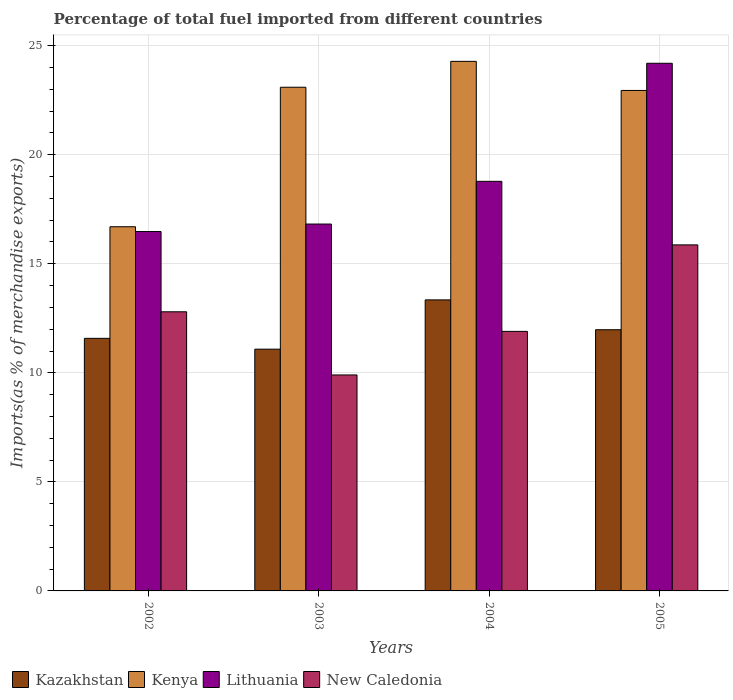How many groups of bars are there?
Your answer should be compact. 4. Are the number of bars per tick equal to the number of legend labels?
Your response must be concise. Yes. Are the number of bars on each tick of the X-axis equal?
Your answer should be compact. Yes. How many bars are there on the 1st tick from the right?
Your answer should be compact. 4. What is the label of the 1st group of bars from the left?
Your answer should be very brief. 2002. What is the percentage of imports to different countries in New Caledonia in 2005?
Give a very brief answer. 15.87. Across all years, what is the maximum percentage of imports to different countries in Kenya?
Provide a short and direct response. 24.28. Across all years, what is the minimum percentage of imports to different countries in Lithuania?
Provide a short and direct response. 16.48. In which year was the percentage of imports to different countries in New Caledonia maximum?
Provide a short and direct response. 2005. In which year was the percentage of imports to different countries in New Caledonia minimum?
Your answer should be very brief. 2003. What is the total percentage of imports to different countries in New Caledonia in the graph?
Keep it short and to the point. 50.47. What is the difference between the percentage of imports to different countries in New Caledonia in 2002 and that in 2004?
Keep it short and to the point. 0.9. What is the difference between the percentage of imports to different countries in Kenya in 2005 and the percentage of imports to different countries in New Caledonia in 2004?
Your answer should be very brief. 11.05. What is the average percentage of imports to different countries in Lithuania per year?
Offer a very short reply. 19.07. In the year 2005, what is the difference between the percentage of imports to different countries in New Caledonia and percentage of imports to different countries in Lithuania?
Your answer should be very brief. -8.33. In how many years, is the percentage of imports to different countries in Kenya greater than 4 %?
Your answer should be compact. 4. What is the ratio of the percentage of imports to different countries in New Caledonia in 2003 to that in 2004?
Provide a succinct answer. 0.83. Is the percentage of imports to different countries in Lithuania in 2003 less than that in 2005?
Provide a short and direct response. Yes. What is the difference between the highest and the second highest percentage of imports to different countries in New Caledonia?
Offer a terse response. 3.07. What is the difference between the highest and the lowest percentage of imports to different countries in Lithuania?
Make the answer very short. 7.72. Is the sum of the percentage of imports to different countries in Kenya in 2003 and 2005 greater than the maximum percentage of imports to different countries in Lithuania across all years?
Provide a succinct answer. Yes. Is it the case that in every year, the sum of the percentage of imports to different countries in New Caledonia and percentage of imports to different countries in Lithuania is greater than the sum of percentage of imports to different countries in Kenya and percentage of imports to different countries in Kazakhstan?
Keep it short and to the point. No. What does the 3rd bar from the left in 2003 represents?
Offer a terse response. Lithuania. What does the 1st bar from the right in 2005 represents?
Ensure brevity in your answer.  New Caledonia. What is the difference between two consecutive major ticks on the Y-axis?
Ensure brevity in your answer.  5. Are the values on the major ticks of Y-axis written in scientific E-notation?
Provide a short and direct response. No. Does the graph contain any zero values?
Provide a short and direct response. No. Does the graph contain grids?
Offer a very short reply. Yes. Where does the legend appear in the graph?
Ensure brevity in your answer.  Bottom left. How are the legend labels stacked?
Ensure brevity in your answer.  Horizontal. What is the title of the graph?
Give a very brief answer. Percentage of total fuel imported from different countries. What is the label or title of the Y-axis?
Ensure brevity in your answer.  Imports(as % of merchandise exports). What is the Imports(as % of merchandise exports) in Kazakhstan in 2002?
Provide a succinct answer. 11.58. What is the Imports(as % of merchandise exports) in Kenya in 2002?
Provide a succinct answer. 16.7. What is the Imports(as % of merchandise exports) of Lithuania in 2002?
Provide a short and direct response. 16.48. What is the Imports(as % of merchandise exports) in New Caledonia in 2002?
Provide a short and direct response. 12.8. What is the Imports(as % of merchandise exports) in Kazakhstan in 2003?
Provide a succinct answer. 11.09. What is the Imports(as % of merchandise exports) in Kenya in 2003?
Ensure brevity in your answer.  23.1. What is the Imports(as % of merchandise exports) of Lithuania in 2003?
Provide a short and direct response. 16.82. What is the Imports(as % of merchandise exports) in New Caledonia in 2003?
Ensure brevity in your answer.  9.9. What is the Imports(as % of merchandise exports) in Kazakhstan in 2004?
Your answer should be very brief. 13.35. What is the Imports(as % of merchandise exports) in Kenya in 2004?
Offer a terse response. 24.28. What is the Imports(as % of merchandise exports) in Lithuania in 2004?
Make the answer very short. 18.78. What is the Imports(as % of merchandise exports) in New Caledonia in 2004?
Keep it short and to the point. 11.9. What is the Imports(as % of merchandise exports) in Kazakhstan in 2005?
Your answer should be compact. 11.98. What is the Imports(as % of merchandise exports) in Kenya in 2005?
Offer a terse response. 22.95. What is the Imports(as % of merchandise exports) of Lithuania in 2005?
Keep it short and to the point. 24.2. What is the Imports(as % of merchandise exports) of New Caledonia in 2005?
Give a very brief answer. 15.87. Across all years, what is the maximum Imports(as % of merchandise exports) of Kazakhstan?
Make the answer very short. 13.35. Across all years, what is the maximum Imports(as % of merchandise exports) of Kenya?
Your answer should be very brief. 24.28. Across all years, what is the maximum Imports(as % of merchandise exports) of Lithuania?
Provide a short and direct response. 24.2. Across all years, what is the maximum Imports(as % of merchandise exports) of New Caledonia?
Provide a short and direct response. 15.87. Across all years, what is the minimum Imports(as % of merchandise exports) in Kazakhstan?
Your answer should be very brief. 11.09. Across all years, what is the minimum Imports(as % of merchandise exports) of Kenya?
Provide a succinct answer. 16.7. Across all years, what is the minimum Imports(as % of merchandise exports) of Lithuania?
Give a very brief answer. 16.48. Across all years, what is the minimum Imports(as % of merchandise exports) of New Caledonia?
Make the answer very short. 9.9. What is the total Imports(as % of merchandise exports) in Kazakhstan in the graph?
Offer a terse response. 47.99. What is the total Imports(as % of merchandise exports) in Kenya in the graph?
Your answer should be very brief. 87.03. What is the total Imports(as % of merchandise exports) in Lithuania in the graph?
Give a very brief answer. 76.28. What is the total Imports(as % of merchandise exports) in New Caledonia in the graph?
Offer a terse response. 50.47. What is the difference between the Imports(as % of merchandise exports) of Kazakhstan in 2002 and that in 2003?
Your response must be concise. 0.5. What is the difference between the Imports(as % of merchandise exports) of Kenya in 2002 and that in 2003?
Offer a terse response. -6.4. What is the difference between the Imports(as % of merchandise exports) in Lithuania in 2002 and that in 2003?
Provide a succinct answer. -0.34. What is the difference between the Imports(as % of merchandise exports) of New Caledonia in 2002 and that in 2003?
Offer a terse response. 2.9. What is the difference between the Imports(as % of merchandise exports) in Kazakhstan in 2002 and that in 2004?
Give a very brief answer. -1.76. What is the difference between the Imports(as % of merchandise exports) of Kenya in 2002 and that in 2004?
Make the answer very short. -7.58. What is the difference between the Imports(as % of merchandise exports) in Lithuania in 2002 and that in 2004?
Offer a very short reply. -2.3. What is the difference between the Imports(as % of merchandise exports) of New Caledonia in 2002 and that in 2004?
Keep it short and to the point. 0.9. What is the difference between the Imports(as % of merchandise exports) in Kazakhstan in 2002 and that in 2005?
Ensure brevity in your answer.  -0.4. What is the difference between the Imports(as % of merchandise exports) in Kenya in 2002 and that in 2005?
Provide a succinct answer. -6.25. What is the difference between the Imports(as % of merchandise exports) of Lithuania in 2002 and that in 2005?
Make the answer very short. -7.72. What is the difference between the Imports(as % of merchandise exports) of New Caledonia in 2002 and that in 2005?
Provide a succinct answer. -3.07. What is the difference between the Imports(as % of merchandise exports) in Kazakhstan in 2003 and that in 2004?
Ensure brevity in your answer.  -2.26. What is the difference between the Imports(as % of merchandise exports) in Kenya in 2003 and that in 2004?
Make the answer very short. -1.19. What is the difference between the Imports(as % of merchandise exports) in Lithuania in 2003 and that in 2004?
Provide a succinct answer. -1.96. What is the difference between the Imports(as % of merchandise exports) in New Caledonia in 2003 and that in 2004?
Your answer should be compact. -2. What is the difference between the Imports(as % of merchandise exports) in Kazakhstan in 2003 and that in 2005?
Your response must be concise. -0.89. What is the difference between the Imports(as % of merchandise exports) of Kenya in 2003 and that in 2005?
Provide a succinct answer. 0.15. What is the difference between the Imports(as % of merchandise exports) of Lithuania in 2003 and that in 2005?
Your answer should be compact. -7.37. What is the difference between the Imports(as % of merchandise exports) in New Caledonia in 2003 and that in 2005?
Offer a terse response. -5.96. What is the difference between the Imports(as % of merchandise exports) of Kazakhstan in 2004 and that in 2005?
Ensure brevity in your answer.  1.37. What is the difference between the Imports(as % of merchandise exports) of Kenya in 2004 and that in 2005?
Your response must be concise. 1.33. What is the difference between the Imports(as % of merchandise exports) in Lithuania in 2004 and that in 2005?
Offer a terse response. -5.41. What is the difference between the Imports(as % of merchandise exports) in New Caledonia in 2004 and that in 2005?
Keep it short and to the point. -3.97. What is the difference between the Imports(as % of merchandise exports) in Kazakhstan in 2002 and the Imports(as % of merchandise exports) in Kenya in 2003?
Your answer should be very brief. -11.51. What is the difference between the Imports(as % of merchandise exports) in Kazakhstan in 2002 and the Imports(as % of merchandise exports) in Lithuania in 2003?
Your response must be concise. -5.24. What is the difference between the Imports(as % of merchandise exports) of Kazakhstan in 2002 and the Imports(as % of merchandise exports) of New Caledonia in 2003?
Your response must be concise. 1.68. What is the difference between the Imports(as % of merchandise exports) of Kenya in 2002 and the Imports(as % of merchandise exports) of Lithuania in 2003?
Your answer should be very brief. -0.12. What is the difference between the Imports(as % of merchandise exports) of Kenya in 2002 and the Imports(as % of merchandise exports) of New Caledonia in 2003?
Your answer should be compact. 6.8. What is the difference between the Imports(as % of merchandise exports) of Lithuania in 2002 and the Imports(as % of merchandise exports) of New Caledonia in 2003?
Offer a terse response. 6.58. What is the difference between the Imports(as % of merchandise exports) in Kazakhstan in 2002 and the Imports(as % of merchandise exports) in Kenya in 2004?
Make the answer very short. -12.7. What is the difference between the Imports(as % of merchandise exports) in Kazakhstan in 2002 and the Imports(as % of merchandise exports) in Lithuania in 2004?
Your answer should be very brief. -7.2. What is the difference between the Imports(as % of merchandise exports) in Kazakhstan in 2002 and the Imports(as % of merchandise exports) in New Caledonia in 2004?
Ensure brevity in your answer.  -0.32. What is the difference between the Imports(as % of merchandise exports) in Kenya in 2002 and the Imports(as % of merchandise exports) in Lithuania in 2004?
Give a very brief answer. -2.08. What is the difference between the Imports(as % of merchandise exports) of Kenya in 2002 and the Imports(as % of merchandise exports) of New Caledonia in 2004?
Offer a very short reply. 4.8. What is the difference between the Imports(as % of merchandise exports) of Lithuania in 2002 and the Imports(as % of merchandise exports) of New Caledonia in 2004?
Your response must be concise. 4.58. What is the difference between the Imports(as % of merchandise exports) of Kazakhstan in 2002 and the Imports(as % of merchandise exports) of Kenya in 2005?
Your answer should be very brief. -11.37. What is the difference between the Imports(as % of merchandise exports) in Kazakhstan in 2002 and the Imports(as % of merchandise exports) in Lithuania in 2005?
Offer a very short reply. -12.61. What is the difference between the Imports(as % of merchandise exports) in Kazakhstan in 2002 and the Imports(as % of merchandise exports) in New Caledonia in 2005?
Ensure brevity in your answer.  -4.29. What is the difference between the Imports(as % of merchandise exports) in Kenya in 2002 and the Imports(as % of merchandise exports) in Lithuania in 2005?
Your response must be concise. -7.5. What is the difference between the Imports(as % of merchandise exports) in Kenya in 2002 and the Imports(as % of merchandise exports) in New Caledonia in 2005?
Give a very brief answer. 0.83. What is the difference between the Imports(as % of merchandise exports) of Lithuania in 2002 and the Imports(as % of merchandise exports) of New Caledonia in 2005?
Offer a terse response. 0.61. What is the difference between the Imports(as % of merchandise exports) in Kazakhstan in 2003 and the Imports(as % of merchandise exports) in Kenya in 2004?
Give a very brief answer. -13.2. What is the difference between the Imports(as % of merchandise exports) of Kazakhstan in 2003 and the Imports(as % of merchandise exports) of Lithuania in 2004?
Keep it short and to the point. -7.7. What is the difference between the Imports(as % of merchandise exports) in Kazakhstan in 2003 and the Imports(as % of merchandise exports) in New Caledonia in 2004?
Ensure brevity in your answer.  -0.82. What is the difference between the Imports(as % of merchandise exports) in Kenya in 2003 and the Imports(as % of merchandise exports) in Lithuania in 2004?
Keep it short and to the point. 4.31. What is the difference between the Imports(as % of merchandise exports) in Kenya in 2003 and the Imports(as % of merchandise exports) in New Caledonia in 2004?
Your response must be concise. 11.2. What is the difference between the Imports(as % of merchandise exports) of Lithuania in 2003 and the Imports(as % of merchandise exports) of New Caledonia in 2004?
Offer a very short reply. 4.92. What is the difference between the Imports(as % of merchandise exports) in Kazakhstan in 2003 and the Imports(as % of merchandise exports) in Kenya in 2005?
Provide a short and direct response. -11.86. What is the difference between the Imports(as % of merchandise exports) of Kazakhstan in 2003 and the Imports(as % of merchandise exports) of Lithuania in 2005?
Keep it short and to the point. -13.11. What is the difference between the Imports(as % of merchandise exports) in Kazakhstan in 2003 and the Imports(as % of merchandise exports) in New Caledonia in 2005?
Make the answer very short. -4.78. What is the difference between the Imports(as % of merchandise exports) in Kenya in 2003 and the Imports(as % of merchandise exports) in Lithuania in 2005?
Give a very brief answer. -1.1. What is the difference between the Imports(as % of merchandise exports) in Kenya in 2003 and the Imports(as % of merchandise exports) in New Caledonia in 2005?
Ensure brevity in your answer.  7.23. What is the difference between the Imports(as % of merchandise exports) of Lithuania in 2003 and the Imports(as % of merchandise exports) of New Caledonia in 2005?
Your answer should be very brief. 0.96. What is the difference between the Imports(as % of merchandise exports) of Kazakhstan in 2004 and the Imports(as % of merchandise exports) of Kenya in 2005?
Your answer should be compact. -9.6. What is the difference between the Imports(as % of merchandise exports) of Kazakhstan in 2004 and the Imports(as % of merchandise exports) of Lithuania in 2005?
Make the answer very short. -10.85. What is the difference between the Imports(as % of merchandise exports) of Kazakhstan in 2004 and the Imports(as % of merchandise exports) of New Caledonia in 2005?
Make the answer very short. -2.52. What is the difference between the Imports(as % of merchandise exports) in Kenya in 2004 and the Imports(as % of merchandise exports) in Lithuania in 2005?
Give a very brief answer. 0.09. What is the difference between the Imports(as % of merchandise exports) of Kenya in 2004 and the Imports(as % of merchandise exports) of New Caledonia in 2005?
Provide a short and direct response. 8.42. What is the difference between the Imports(as % of merchandise exports) in Lithuania in 2004 and the Imports(as % of merchandise exports) in New Caledonia in 2005?
Your answer should be very brief. 2.91. What is the average Imports(as % of merchandise exports) in Kazakhstan per year?
Offer a very short reply. 12. What is the average Imports(as % of merchandise exports) of Kenya per year?
Make the answer very short. 21.76. What is the average Imports(as % of merchandise exports) in Lithuania per year?
Offer a terse response. 19.07. What is the average Imports(as % of merchandise exports) in New Caledonia per year?
Keep it short and to the point. 12.62. In the year 2002, what is the difference between the Imports(as % of merchandise exports) of Kazakhstan and Imports(as % of merchandise exports) of Kenya?
Provide a short and direct response. -5.12. In the year 2002, what is the difference between the Imports(as % of merchandise exports) in Kazakhstan and Imports(as % of merchandise exports) in Lithuania?
Provide a succinct answer. -4.9. In the year 2002, what is the difference between the Imports(as % of merchandise exports) of Kazakhstan and Imports(as % of merchandise exports) of New Caledonia?
Your answer should be very brief. -1.22. In the year 2002, what is the difference between the Imports(as % of merchandise exports) of Kenya and Imports(as % of merchandise exports) of Lithuania?
Keep it short and to the point. 0.22. In the year 2002, what is the difference between the Imports(as % of merchandise exports) in Kenya and Imports(as % of merchandise exports) in New Caledonia?
Offer a very short reply. 3.9. In the year 2002, what is the difference between the Imports(as % of merchandise exports) in Lithuania and Imports(as % of merchandise exports) in New Caledonia?
Offer a terse response. 3.68. In the year 2003, what is the difference between the Imports(as % of merchandise exports) in Kazakhstan and Imports(as % of merchandise exports) in Kenya?
Your answer should be very brief. -12.01. In the year 2003, what is the difference between the Imports(as % of merchandise exports) of Kazakhstan and Imports(as % of merchandise exports) of Lithuania?
Provide a short and direct response. -5.74. In the year 2003, what is the difference between the Imports(as % of merchandise exports) in Kazakhstan and Imports(as % of merchandise exports) in New Caledonia?
Your answer should be very brief. 1.18. In the year 2003, what is the difference between the Imports(as % of merchandise exports) in Kenya and Imports(as % of merchandise exports) in Lithuania?
Your response must be concise. 6.27. In the year 2003, what is the difference between the Imports(as % of merchandise exports) of Kenya and Imports(as % of merchandise exports) of New Caledonia?
Offer a very short reply. 13.19. In the year 2003, what is the difference between the Imports(as % of merchandise exports) in Lithuania and Imports(as % of merchandise exports) in New Caledonia?
Offer a very short reply. 6.92. In the year 2004, what is the difference between the Imports(as % of merchandise exports) of Kazakhstan and Imports(as % of merchandise exports) of Kenya?
Offer a very short reply. -10.94. In the year 2004, what is the difference between the Imports(as % of merchandise exports) of Kazakhstan and Imports(as % of merchandise exports) of Lithuania?
Give a very brief answer. -5.44. In the year 2004, what is the difference between the Imports(as % of merchandise exports) of Kazakhstan and Imports(as % of merchandise exports) of New Caledonia?
Your response must be concise. 1.44. In the year 2004, what is the difference between the Imports(as % of merchandise exports) in Kenya and Imports(as % of merchandise exports) in Lithuania?
Make the answer very short. 5.5. In the year 2004, what is the difference between the Imports(as % of merchandise exports) of Kenya and Imports(as % of merchandise exports) of New Caledonia?
Offer a very short reply. 12.38. In the year 2004, what is the difference between the Imports(as % of merchandise exports) in Lithuania and Imports(as % of merchandise exports) in New Caledonia?
Your answer should be compact. 6.88. In the year 2005, what is the difference between the Imports(as % of merchandise exports) in Kazakhstan and Imports(as % of merchandise exports) in Kenya?
Your response must be concise. -10.97. In the year 2005, what is the difference between the Imports(as % of merchandise exports) in Kazakhstan and Imports(as % of merchandise exports) in Lithuania?
Your answer should be compact. -12.22. In the year 2005, what is the difference between the Imports(as % of merchandise exports) of Kazakhstan and Imports(as % of merchandise exports) of New Caledonia?
Your response must be concise. -3.89. In the year 2005, what is the difference between the Imports(as % of merchandise exports) in Kenya and Imports(as % of merchandise exports) in Lithuania?
Your response must be concise. -1.25. In the year 2005, what is the difference between the Imports(as % of merchandise exports) in Kenya and Imports(as % of merchandise exports) in New Caledonia?
Offer a terse response. 7.08. In the year 2005, what is the difference between the Imports(as % of merchandise exports) of Lithuania and Imports(as % of merchandise exports) of New Caledonia?
Offer a terse response. 8.33. What is the ratio of the Imports(as % of merchandise exports) in Kazakhstan in 2002 to that in 2003?
Ensure brevity in your answer.  1.04. What is the ratio of the Imports(as % of merchandise exports) of Kenya in 2002 to that in 2003?
Offer a terse response. 0.72. What is the ratio of the Imports(as % of merchandise exports) in Lithuania in 2002 to that in 2003?
Give a very brief answer. 0.98. What is the ratio of the Imports(as % of merchandise exports) in New Caledonia in 2002 to that in 2003?
Offer a terse response. 1.29. What is the ratio of the Imports(as % of merchandise exports) of Kazakhstan in 2002 to that in 2004?
Offer a terse response. 0.87. What is the ratio of the Imports(as % of merchandise exports) in Kenya in 2002 to that in 2004?
Make the answer very short. 0.69. What is the ratio of the Imports(as % of merchandise exports) in Lithuania in 2002 to that in 2004?
Your answer should be compact. 0.88. What is the ratio of the Imports(as % of merchandise exports) in New Caledonia in 2002 to that in 2004?
Offer a very short reply. 1.08. What is the ratio of the Imports(as % of merchandise exports) in Kazakhstan in 2002 to that in 2005?
Keep it short and to the point. 0.97. What is the ratio of the Imports(as % of merchandise exports) in Kenya in 2002 to that in 2005?
Ensure brevity in your answer.  0.73. What is the ratio of the Imports(as % of merchandise exports) of Lithuania in 2002 to that in 2005?
Provide a succinct answer. 0.68. What is the ratio of the Imports(as % of merchandise exports) in New Caledonia in 2002 to that in 2005?
Give a very brief answer. 0.81. What is the ratio of the Imports(as % of merchandise exports) of Kazakhstan in 2003 to that in 2004?
Offer a very short reply. 0.83. What is the ratio of the Imports(as % of merchandise exports) in Kenya in 2003 to that in 2004?
Keep it short and to the point. 0.95. What is the ratio of the Imports(as % of merchandise exports) in Lithuania in 2003 to that in 2004?
Your answer should be very brief. 0.9. What is the ratio of the Imports(as % of merchandise exports) in New Caledonia in 2003 to that in 2004?
Offer a very short reply. 0.83. What is the ratio of the Imports(as % of merchandise exports) of Kazakhstan in 2003 to that in 2005?
Offer a very short reply. 0.93. What is the ratio of the Imports(as % of merchandise exports) of Kenya in 2003 to that in 2005?
Ensure brevity in your answer.  1.01. What is the ratio of the Imports(as % of merchandise exports) of Lithuania in 2003 to that in 2005?
Provide a succinct answer. 0.7. What is the ratio of the Imports(as % of merchandise exports) in New Caledonia in 2003 to that in 2005?
Provide a short and direct response. 0.62. What is the ratio of the Imports(as % of merchandise exports) of Kazakhstan in 2004 to that in 2005?
Offer a very short reply. 1.11. What is the ratio of the Imports(as % of merchandise exports) of Kenya in 2004 to that in 2005?
Provide a short and direct response. 1.06. What is the ratio of the Imports(as % of merchandise exports) in Lithuania in 2004 to that in 2005?
Keep it short and to the point. 0.78. What is the ratio of the Imports(as % of merchandise exports) of New Caledonia in 2004 to that in 2005?
Give a very brief answer. 0.75. What is the difference between the highest and the second highest Imports(as % of merchandise exports) of Kazakhstan?
Make the answer very short. 1.37. What is the difference between the highest and the second highest Imports(as % of merchandise exports) in Kenya?
Keep it short and to the point. 1.19. What is the difference between the highest and the second highest Imports(as % of merchandise exports) in Lithuania?
Keep it short and to the point. 5.41. What is the difference between the highest and the second highest Imports(as % of merchandise exports) of New Caledonia?
Your answer should be compact. 3.07. What is the difference between the highest and the lowest Imports(as % of merchandise exports) of Kazakhstan?
Your answer should be compact. 2.26. What is the difference between the highest and the lowest Imports(as % of merchandise exports) in Kenya?
Offer a very short reply. 7.58. What is the difference between the highest and the lowest Imports(as % of merchandise exports) of Lithuania?
Offer a very short reply. 7.72. What is the difference between the highest and the lowest Imports(as % of merchandise exports) of New Caledonia?
Keep it short and to the point. 5.96. 